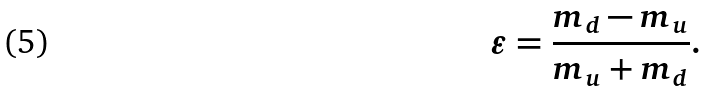Convert formula to latex. <formula><loc_0><loc_0><loc_500><loc_500>\varepsilon = \frac { m _ { d } - m _ { u } } { m _ { u } + m _ { d } } .</formula> 